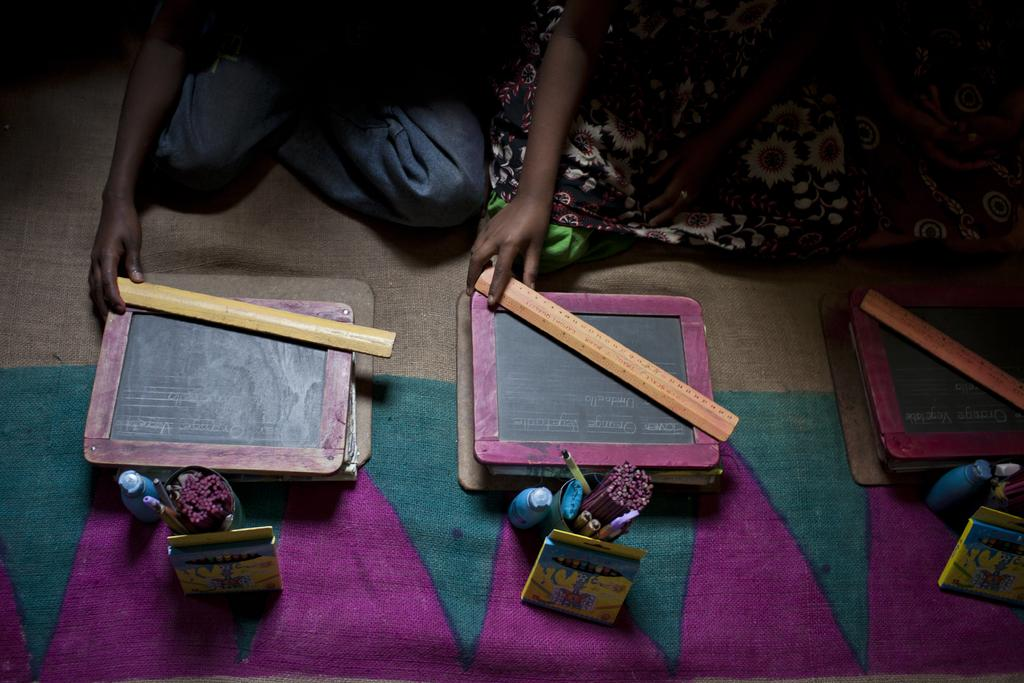What types of objects can be seen in the image? There are slates, clipboards, crayon boxes, pen stands, wooden scales, and objects on a cloth visible in the image. What might be used for writing or drawing in the image? Slates, clipboards, and crayon boxes can be used for writing or drawing in the image. What might be used for holding pens or pencils in the image? Pen stands can be used for holding pens or pencils in the image. What might be used for measuring weight in the image? Wooden scales can be used for measuring weight in the image. How many persons are sitting at the top of the image? There are three persons sitting at the top of the image. What type of volcano can be seen erupting in the image? There is no volcano present in the image. What type of yam is being used as a paperweight on the clipboard? A: There is no yam present in the image, and no paperweight is visible on the clipboard. 